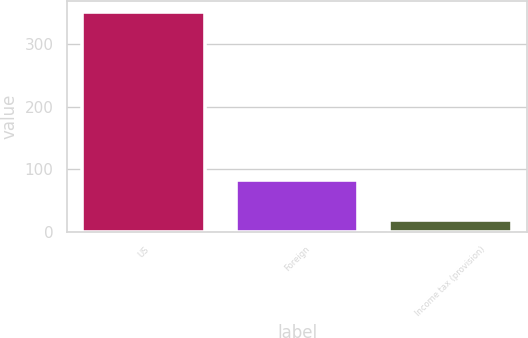Convert chart. <chart><loc_0><loc_0><loc_500><loc_500><bar_chart><fcel>US<fcel>Foreign<fcel>Income tax (provision)<nl><fcel>351<fcel>82<fcel>18<nl></chart> 